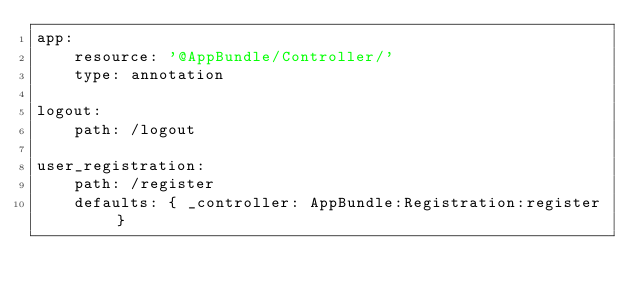Convert code to text. <code><loc_0><loc_0><loc_500><loc_500><_YAML_>app:
    resource: '@AppBundle/Controller/'
    type: annotation

logout:
    path: /logout

user_registration:
    path: /register
    defaults: { _controller: AppBundle:Registration:register }
</code> 